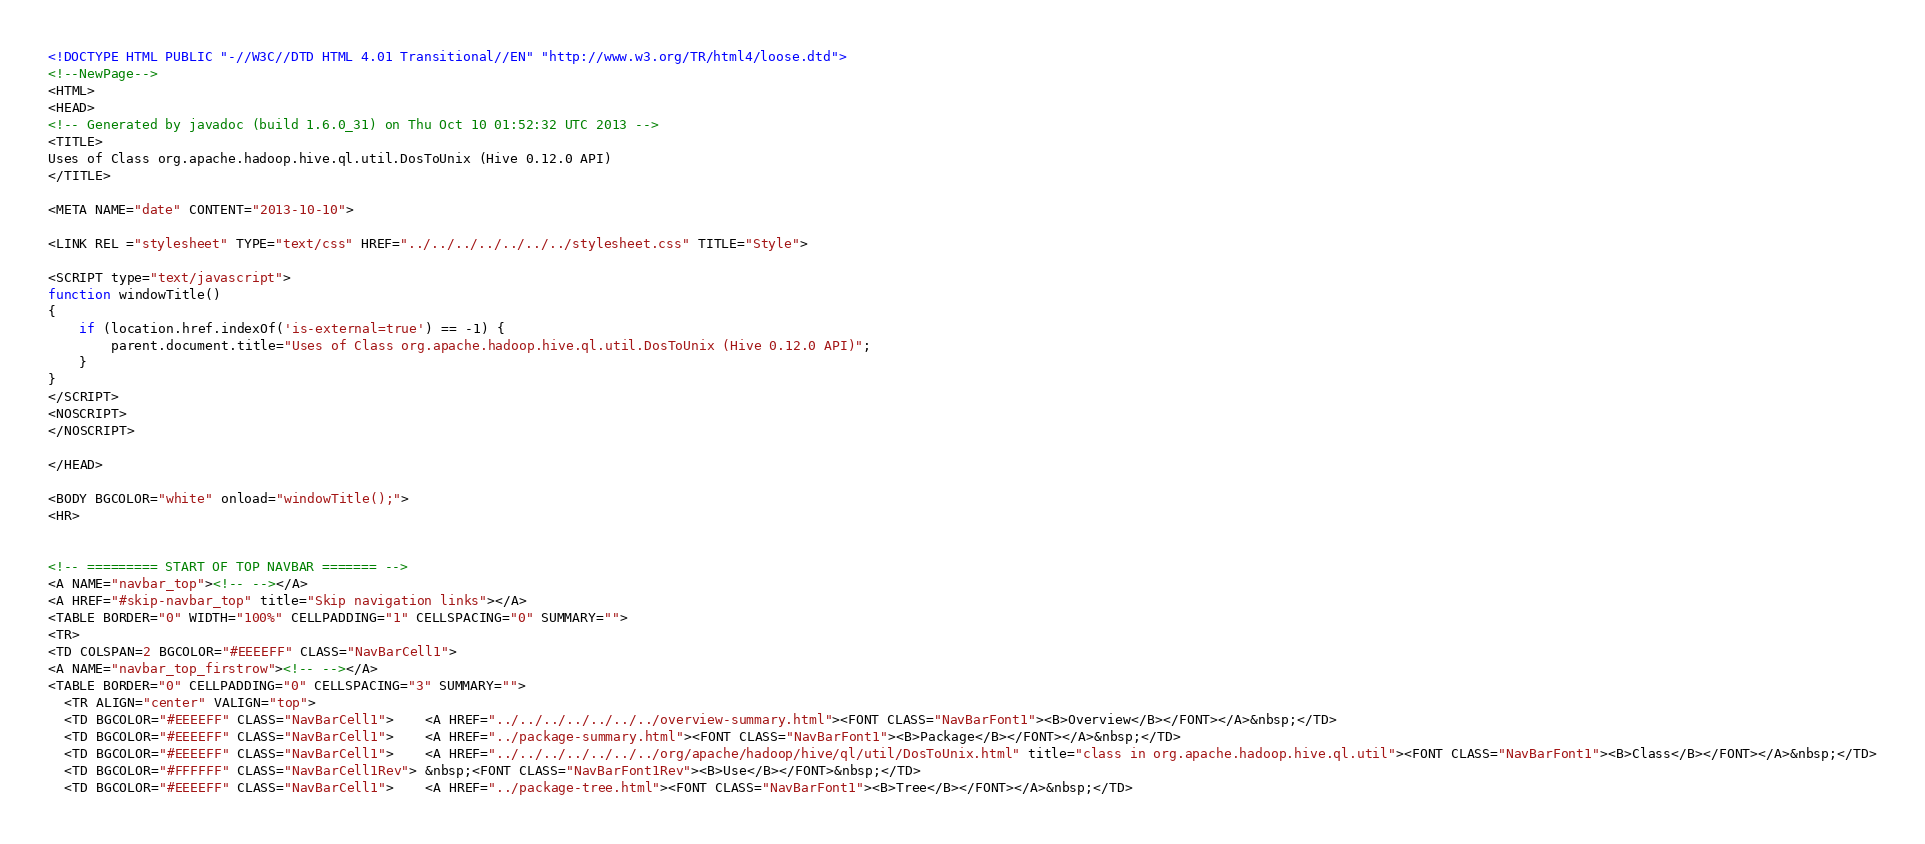Convert code to text. <code><loc_0><loc_0><loc_500><loc_500><_HTML_><!DOCTYPE HTML PUBLIC "-//W3C//DTD HTML 4.01 Transitional//EN" "http://www.w3.org/TR/html4/loose.dtd">
<!--NewPage-->
<HTML>
<HEAD>
<!-- Generated by javadoc (build 1.6.0_31) on Thu Oct 10 01:52:32 UTC 2013 -->
<TITLE>
Uses of Class org.apache.hadoop.hive.ql.util.DosToUnix (Hive 0.12.0 API)
</TITLE>

<META NAME="date" CONTENT="2013-10-10">

<LINK REL ="stylesheet" TYPE="text/css" HREF="../../../../../../../stylesheet.css" TITLE="Style">

<SCRIPT type="text/javascript">
function windowTitle()
{
    if (location.href.indexOf('is-external=true') == -1) {
        parent.document.title="Uses of Class org.apache.hadoop.hive.ql.util.DosToUnix (Hive 0.12.0 API)";
    }
}
</SCRIPT>
<NOSCRIPT>
</NOSCRIPT>

</HEAD>

<BODY BGCOLOR="white" onload="windowTitle();">
<HR>


<!-- ========= START OF TOP NAVBAR ======= -->
<A NAME="navbar_top"><!-- --></A>
<A HREF="#skip-navbar_top" title="Skip navigation links"></A>
<TABLE BORDER="0" WIDTH="100%" CELLPADDING="1" CELLSPACING="0" SUMMARY="">
<TR>
<TD COLSPAN=2 BGCOLOR="#EEEEFF" CLASS="NavBarCell1">
<A NAME="navbar_top_firstrow"><!-- --></A>
<TABLE BORDER="0" CELLPADDING="0" CELLSPACING="3" SUMMARY="">
  <TR ALIGN="center" VALIGN="top">
  <TD BGCOLOR="#EEEEFF" CLASS="NavBarCell1">    <A HREF="../../../../../../../overview-summary.html"><FONT CLASS="NavBarFont1"><B>Overview</B></FONT></A>&nbsp;</TD>
  <TD BGCOLOR="#EEEEFF" CLASS="NavBarCell1">    <A HREF="../package-summary.html"><FONT CLASS="NavBarFont1"><B>Package</B></FONT></A>&nbsp;</TD>
  <TD BGCOLOR="#EEEEFF" CLASS="NavBarCell1">    <A HREF="../../../../../../../org/apache/hadoop/hive/ql/util/DosToUnix.html" title="class in org.apache.hadoop.hive.ql.util"><FONT CLASS="NavBarFont1"><B>Class</B></FONT></A>&nbsp;</TD>
  <TD BGCOLOR="#FFFFFF" CLASS="NavBarCell1Rev"> &nbsp;<FONT CLASS="NavBarFont1Rev"><B>Use</B></FONT>&nbsp;</TD>
  <TD BGCOLOR="#EEEEFF" CLASS="NavBarCell1">    <A HREF="../package-tree.html"><FONT CLASS="NavBarFont1"><B>Tree</B></FONT></A>&nbsp;</TD></code> 